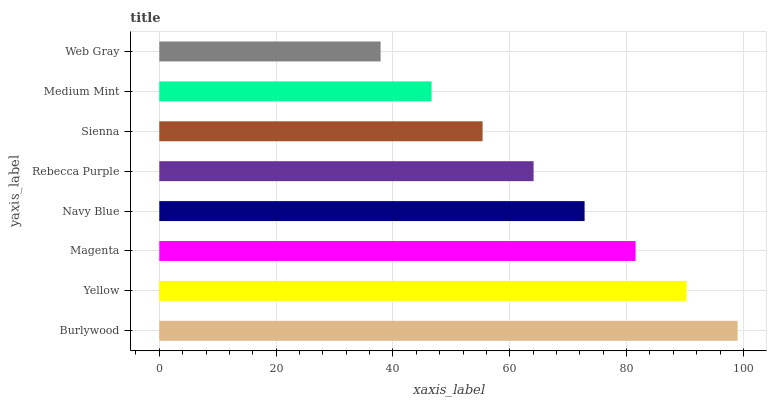Is Web Gray the minimum?
Answer yes or no. Yes. Is Burlywood the maximum?
Answer yes or no. Yes. Is Yellow the minimum?
Answer yes or no. No. Is Yellow the maximum?
Answer yes or no. No. Is Burlywood greater than Yellow?
Answer yes or no. Yes. Is Yellow less than Burlywood?
Answer yes or no. Yes. Is Yellow greater than Burlywood?
Answer yes or no. No. Is Burlywood less than Yellow?
Answer yes or no. No. Is Navy Blue the high median?
Answer yes or no. Yes. Is Rebecca Purple the low median?
Answer yes or no. Yes. Is Rebecca Purple the high median?
Answer yes or no. No. Is Magenta the low median?
Answer yes or no. No. 